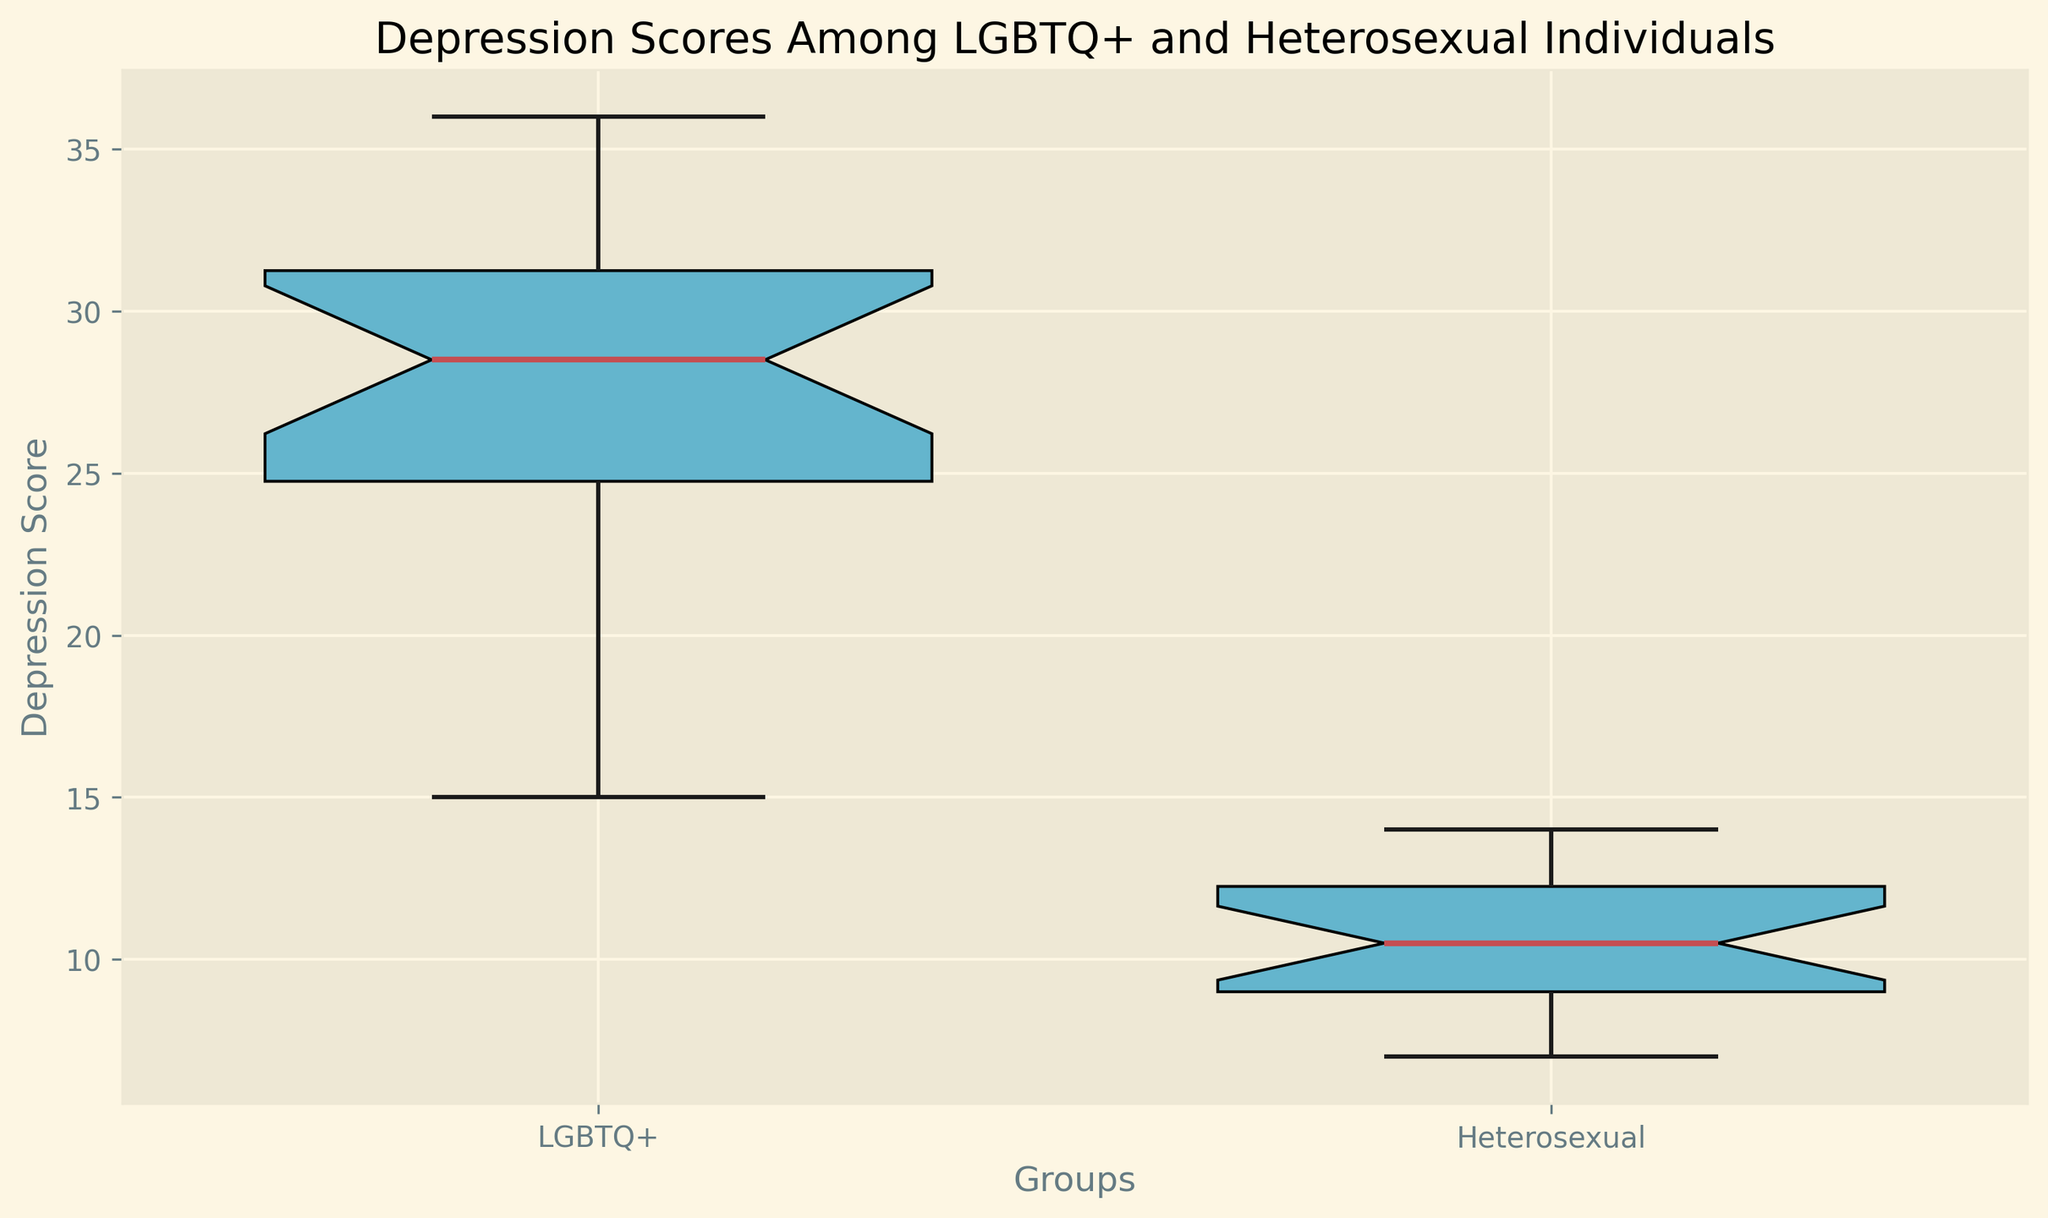What is the median depression score for LGBTQ+ individuals? The box plot shows the median value within the LGBTQ+ group, represented by the central red line inside the box for this group.
Answer: 29 What is the range of depression scores for Heterosexual individuals? The range is obtained by subtracting the lowest value (the bottom whisker) from the highest value (the top whisker) in the box plot for Heterosexual individuals. The highest score is 14 and the lowest score is 7. The range is 14 - 7 = 7.
Answer: 7 Which group has a higher median depression score? Compare the position of the red line (median) within each group's box plot. The LGBTQ+ group has a higher median depression score than the Heterosexual group.
Answer: LGBTQ+ Are there any outliers in either group? Look for individual points that fall outside the whiskers of the box plots. The Heterosexual group has some points marked as yellow circles outside the main range, indicating outliers. The LGBTQ+ group does not have any visible outliers.
Answer: Yes, in Heterosexual group What is the interquartile range (IQR) for the LGBTQ+ group? The IQR is the difference between the third quartile (Q3) and the first quartile (Q1). The top and bottom edges of the box represent these quartiles. If Q3 is 32 and Q1 is 24 (approximate values based on the box plot), then the IQR is 32 - 24 = 8.
Answer: 8 Which group shows a greater variability in depression scores? Variability is indicated by the length of the box (IQR) and the length of the whiskers. The LGBTQ+ group has a longer box and whiskers compared to the Heterosexual group, indicating greater variability.
Answer: LGBTQ+ Is there any overlap in the depression scores between the two groups? Check if the whiskers of the box plots for the two groups overlap. The highest score of the Heterosexual group is within the lower range of the LGBTQ+ group.
Answer: Yes What's the lowest recorded depression score among all the individuals? Look for the lowest point of the bottom whisker across both box plots. For the Heterosexual group, the lowest point is 7.
Answer: 7 What is the difference in the median depression scores between the two groups? Subtract the median value of the Heterosexual group from the median value of the LGBTQ+ group. The median for LGBTQ+ is 29 and for Heterosexual it is 10, so the difference is 29 - 10 = 19.
Answer: 19 